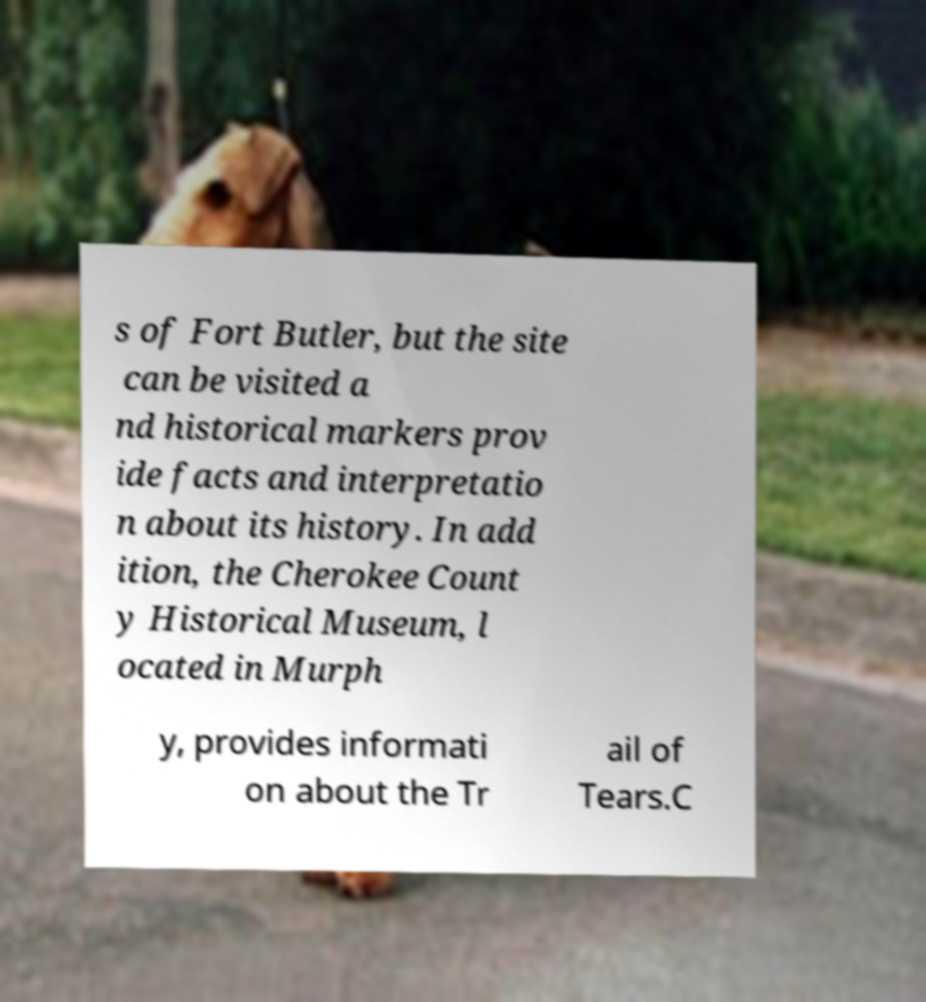Can you accurately transcribe the text from the provided image for me? s of Fort Butler, but the site can be visited a nd historical markers prov ide facts and interpretatio n about its history. In add ition, the Cherokee Count y Historical Museum, l ocated in Murph y, provides informati on about the Tr ail of Tears.C 